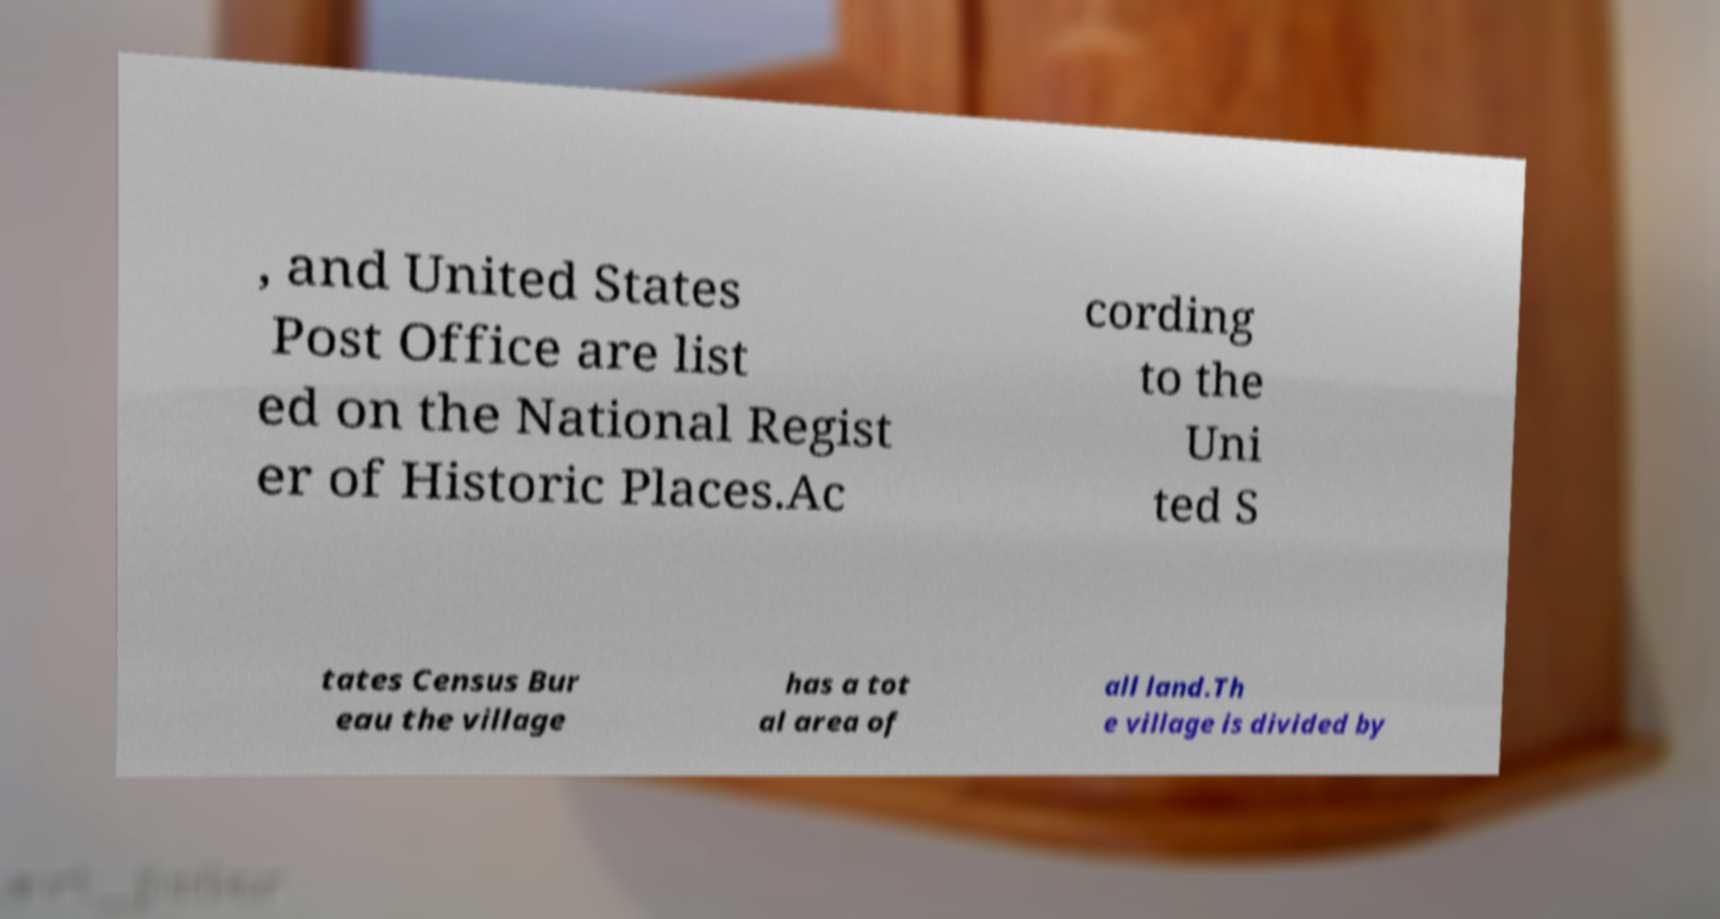Could you assist in decoding the text presented in this image and type it out clearly? , and United States Post Office are list ed on the National Regist er of Historic Places.Ac cording to the Uni ted S tates Census Bur eau the village has a tot al area of all land.Th e village is divided by 